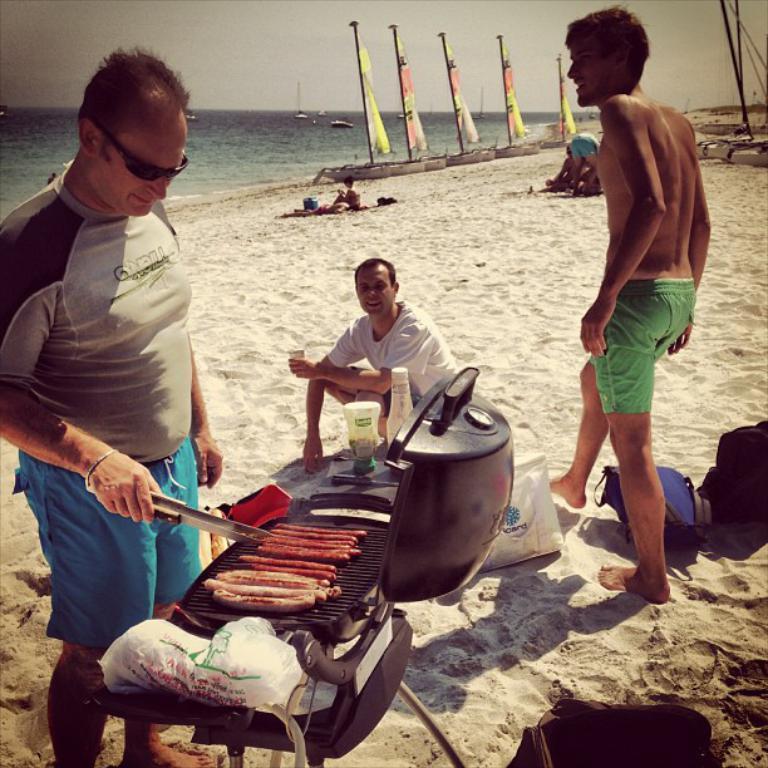In one or two sentences, can you explain what this image depicts? In this image we can see sea shore. There are few people. And there is a grill. On the grill there are sausages. One person is wearing goggles and holding tongs. And we can see bottle and bags. In the back there is water. Also there are flags. In the background there is sky. 